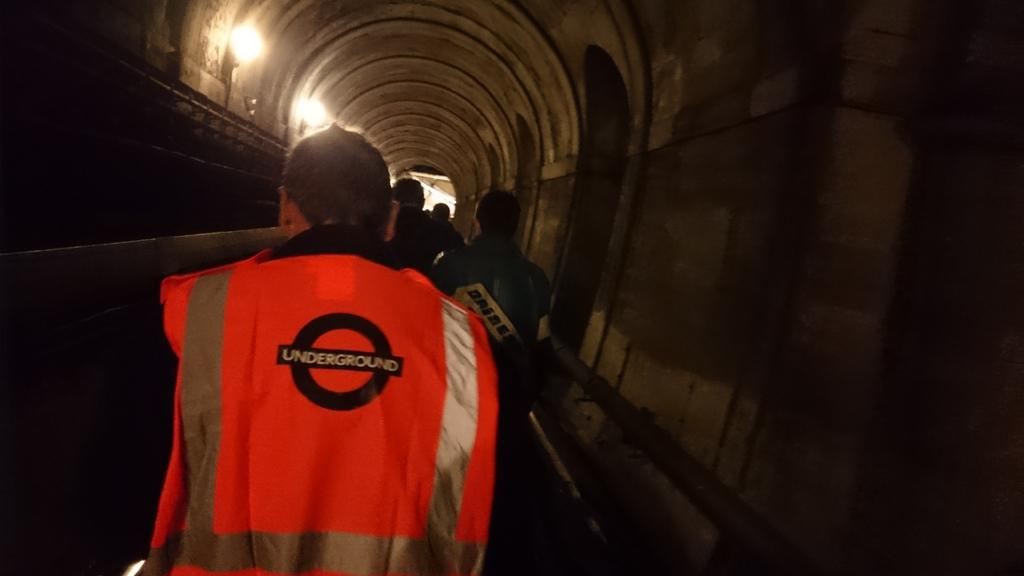<image>
Summarize the visual content of the image. Man wearing a green outfit which says Underground in the back. 